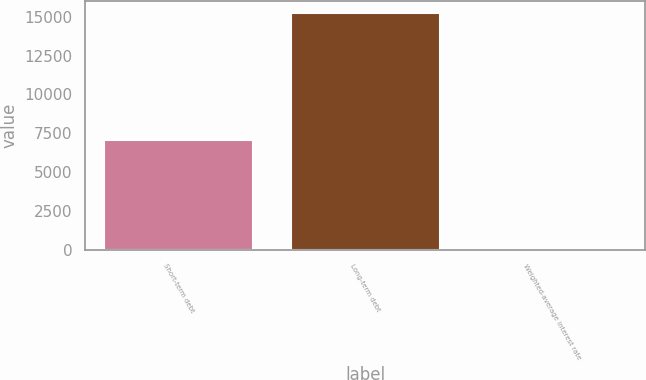<chart> <loc_0><loc_0><loc_500><loc_500><bar_chart><fcel>Short-term debt<fcel>Long-term debt<fcel>Weighted-average interest rate<nl><fcel>7046<fcel>15258<fcel>2<nl></chart> 